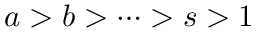Convert formula to latex. <formula><loc_0><loc_0><loc_500><loc_500>a > b > \dots > s > 1</formula> 